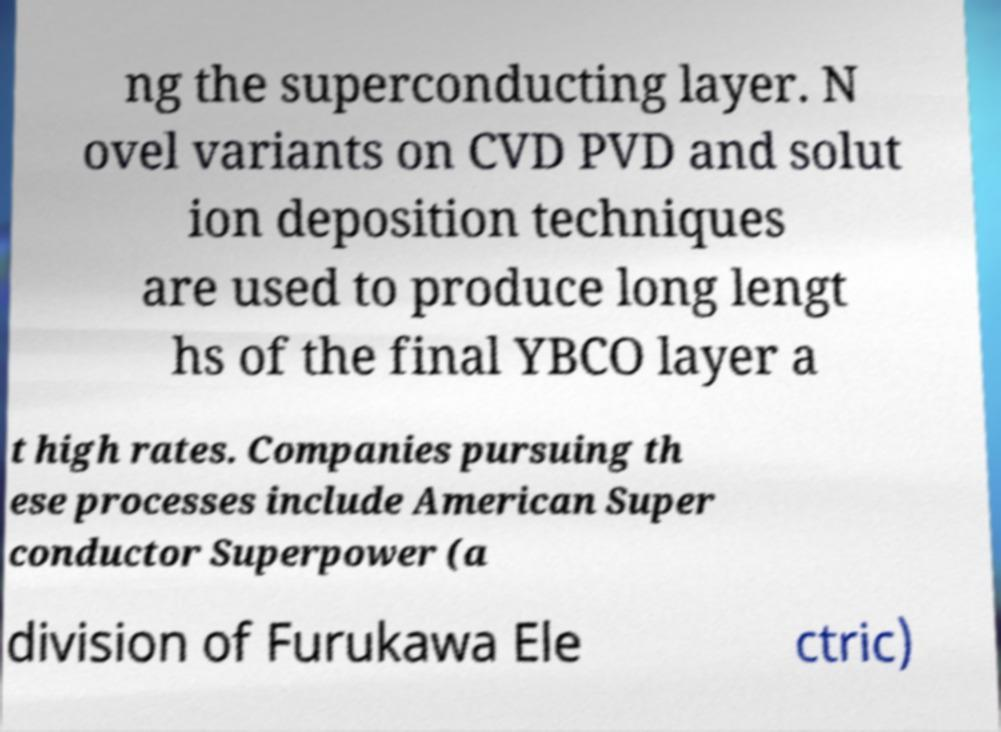There's text embedded in this image that I need extracted. Can you transcribe it verbatim? ng the superconducting layer. N ovel variants on CVD PVD and solut ion deposition techniques are used to produce long lengt hs of the final YBCO layer a t high rates. Companies pursuing th ese processes include American Super conductor Superpower (a division of Furukawa Ele ctric) 